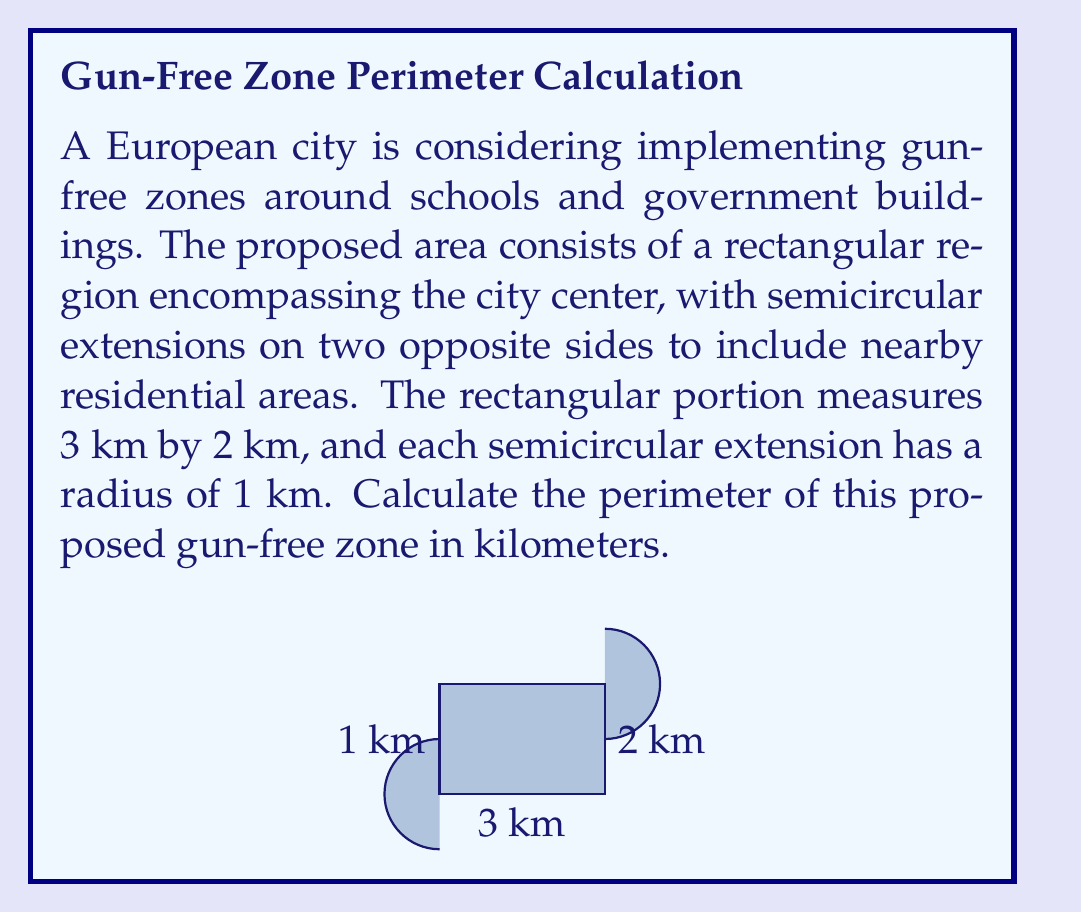Can you solve this math problem? To solve this problem, we need to calculate the perimeter of the entire shape, which consists of:
1. The straight sides of the rectangle
2. The curved parts of the two semicircles

Let's break it down step-by-step:

1. Perimeter of the rectangular portion:
   - Length of the rectangle = 3 km
   - Width of the rectangle = 2 km
   - Perimeter of rectangle = $2(length + width) = 2(3 + 2) = 10$ km

2. Curved part of the semicircles:
   - Radius of each semicircle = 1 km
   - Circumference of a full circle = $2\pi r$
   - For a semicircle, we need half of this: $\pi r$
   - We have two semicircles, so: $2(\pi r) = 2\pi$ km

3. Total perimeter:
   - We add the rectangular perimeter and the curved parts of the semicircles
   - However, we need to subtract the two straight sides of the rectangle that are replaced by the semicircles
   - These sides are each 2 km long

Therefore, the total perimeter is:
$$\text{Perimeter} = 10 + 2\pi - 4 = 6 + 2\pi \text{ km}$$

To get a decimal approximation, we can use $\pi \approx 3.14159$:
$$\text{Perimeter} \approx 6 + 2(3.14159) \approx 12.28318 \text{ km}$$
Answer: The perimeter of the proposed gun-free zone is $6 + 2\pi$ km, or approximately 12.28 km. 